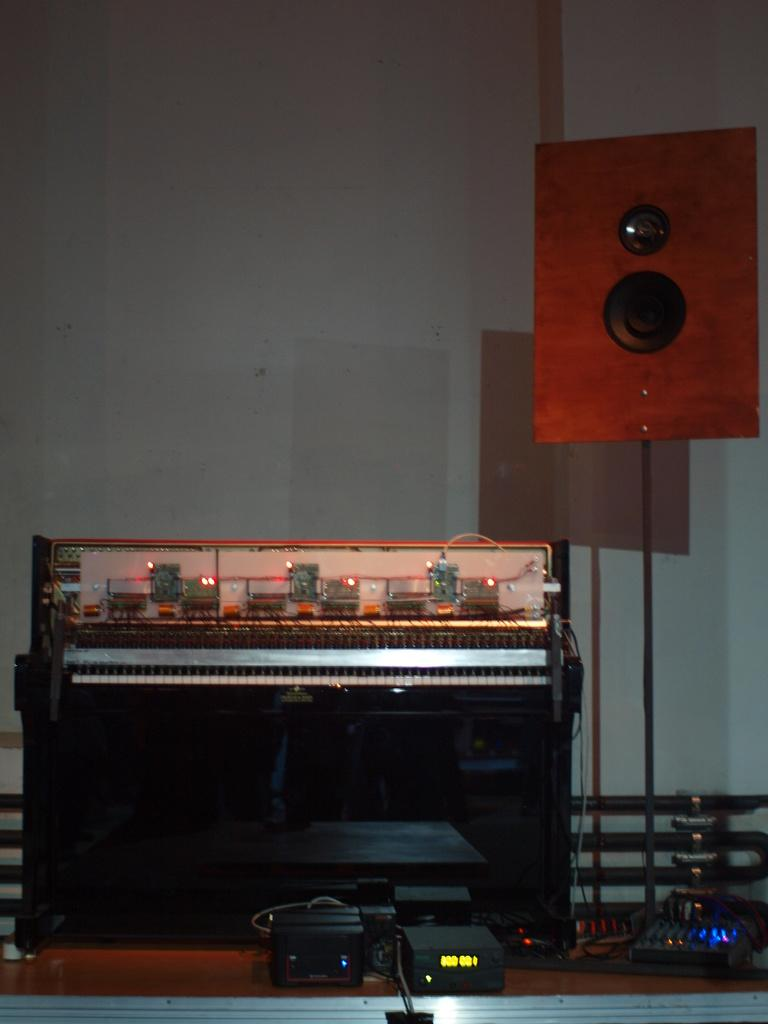What type of objects are present in the image? The image contains musical instruments. Where is the speaker located in the image? The speaker is on the right side of the image. What can be seen at the bottom of the image? There are lights at the bottom of the image. What type of wine is being served on the table in the image? There is no table or wine present in the image; it only contains musical instruments, a speaker, and lights. How is the knot tied in the image? There is no knot present in the image. 